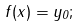Convert formula to latex. <formula><loc_0><loc_0><loc_500><loc_500>f ( x ) = y _ { 0 } ;</formula> 